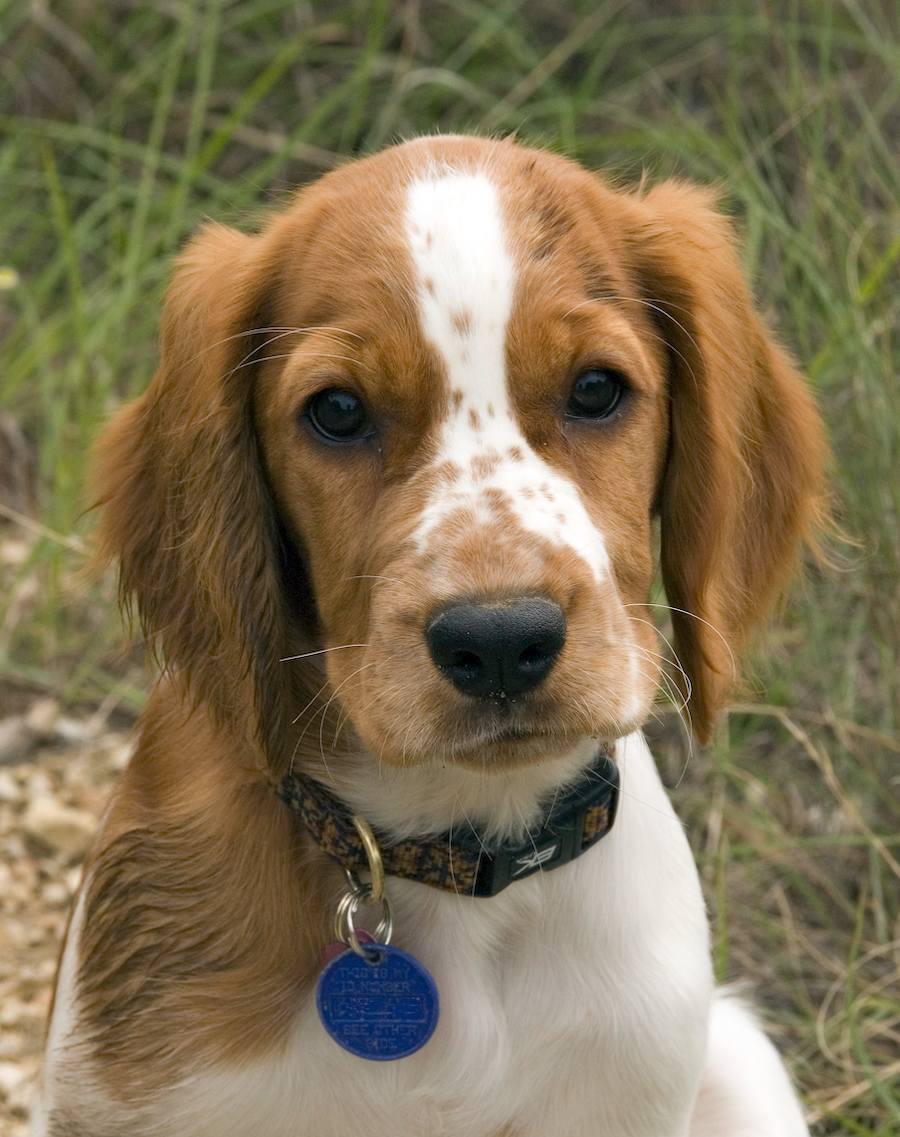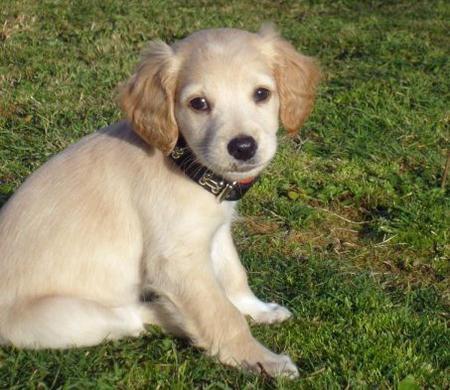The first image is the image on the left, the second image is the image on the right. For the images displayed, is the sentence "The dog in the image on the right is sitting on green grass." factually correct? Answer yes or no. Yes. 